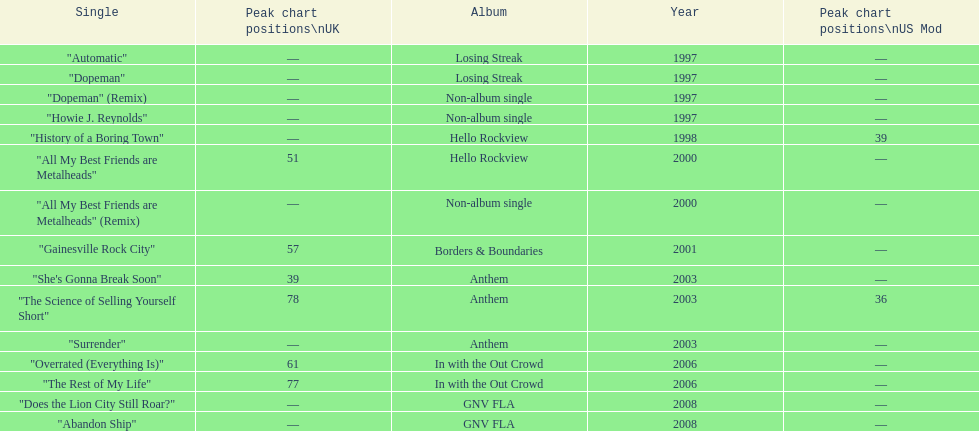Which year has the most singles? 1997. Can you parse all the data within this table? {'header': ['Single', 'Peak chart positions\\nUK', 'Album', 'Year', 'Peak chart positions\\nUS Mod'], 'rows': [['"Automatic"', '—', 'Losing Streak', '1997', '—'], ['"Dopeman"', '—', 'Losing Streak', '1997', '—'], ['"Dopeman" (Remix)', '—', 'Non-album single', '1997', '—'], ['"Howie J. Reynolds"', '—', 'Non-album single', '1997', '—'], ['"History of a Boring Town"', '—', 'Hello Rockview', '1998', '39'], ['"All My Best Friends are Metalheads"', '51', 'Hello Rockview', '2000', '—'], ['"All My Best Friends are Metalheads" (Remix)', '—', 'Non-album single', '2000', '—'], ['"Gainesville Rock City"', '57', 'Borders & Boundaries', '2001', '—'], ['"She\'s Gonna Break Soon"', '39', 'Anthem', '2003', '—'], ['"The Science of Selling Yourself Short"', '78', 'Anthem', '2003', '36'], ['"Surrender"', '—', 'Anthem', '2003', '—'], ['"Overrated (Everything Is)"', '61', 'In with the Out Crowd', '2006', '—'], ['"The Rest of My Life"', '77', 'In with the Out Crowd', '2006', '—'], ['"Does the Lion City Still Roar?"', '—', 'GNV FLA', '2008', '—'], ['"Abandon Ship"', '—', 'GNV FLA', '2008', '—']]} 